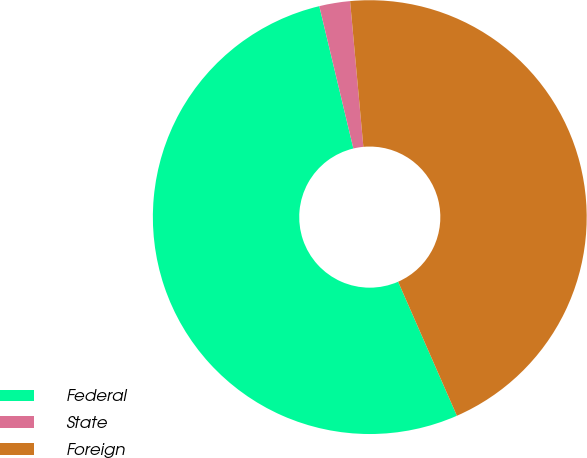<chart> <loc_0><loc_0><loc_500><loc_500><pie_chart><fcel>Federal<fcel>State<fcel>Foreign<nl><fcel>52.84%<fcel>2.29%<fcel>44.87%<nl></chart> 